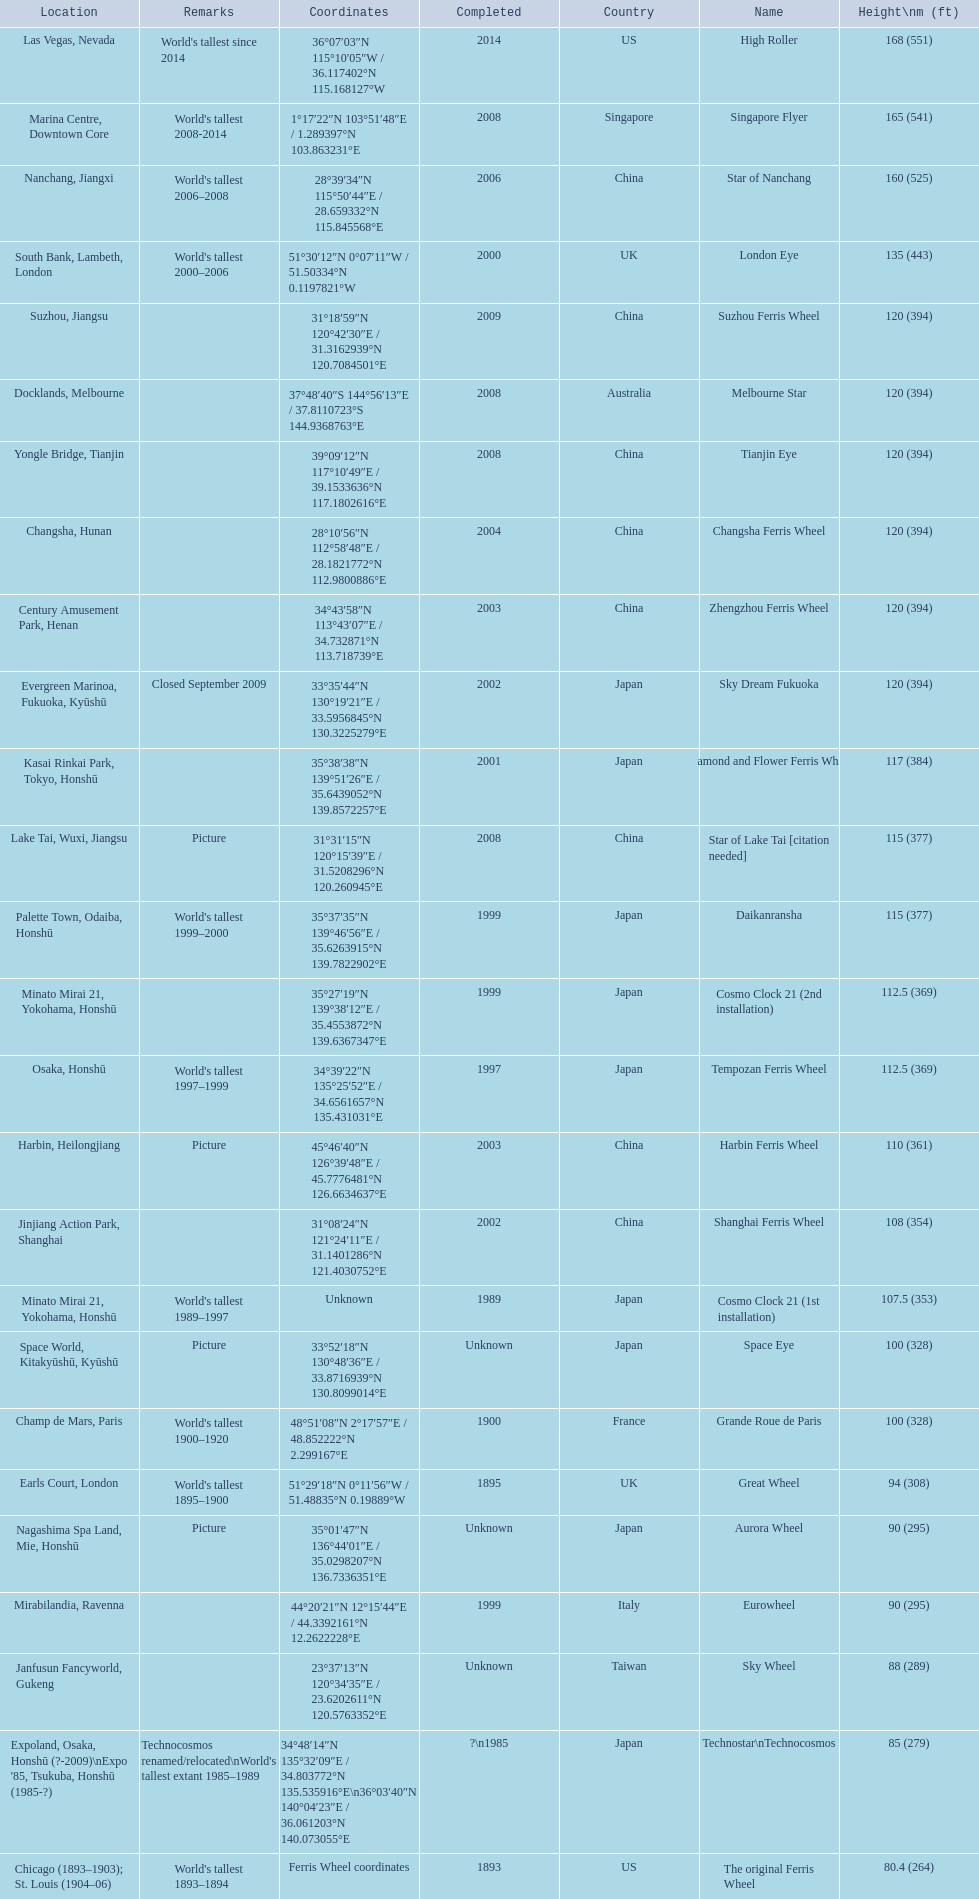What ferris wheels were completed in 2008 Singapore Flyer, Melbourne Star, Tianjin Eye, Star of Lake Tai [citation needed]. Of these, which has the height of 165? Singapore Flyer. 